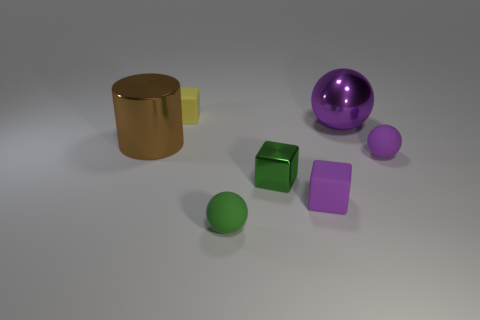Are there any other things that are the same shape as the brown metallic thing?
Your answer should be very brief. No. What is the material of the yellow thing that is the same size as the green rubber object?
Your response must be concise. Rubber. What is the purple object behind the rubber ball that is to the right of the metallic object behind the brown thing made of?
Keep it short and to the point. Metal. The small metal block is what color?
Provide a succinct answer. Green. What number of tiny things are either yellow matte blocks or purple balls?
Provide a short and direct response. 2. What material is the other small object that is the same color as the small metal thing?
Provide a succinct answer. Rubber. Is the material of the small sphere that is right of the small green rubber object the same as the tiny cube on the left side of the green rubber sphere?
Give a very brief answer. Yes. Are there any brown balls?
Your answer should be compact. No. Are there more tiny matte balls on the left side of the purple rubber sphere than purple cubes to the left of the purple matte cube?
Offer a very short reply. Yes. What material is the tiny purple object that is the same shape as the small yellow matte thing?
Provide a succinct answer. Rubber. 